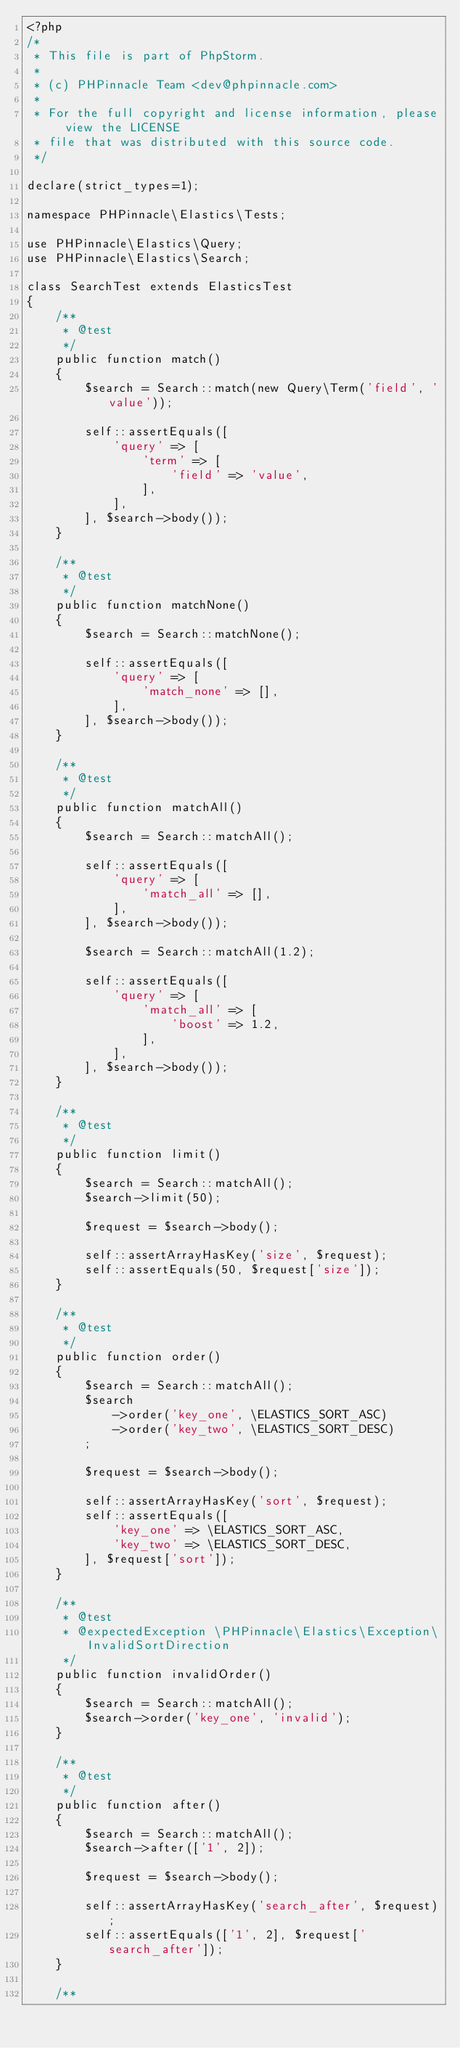<code> <loc_0><loc_0><loc_500><loc_500><_PHP_><?php
/*
 * This file is part of PhpStorm.
 *
 * (c) PHPinnacle Team <dev@phpinnacle.com>
 *
 * For the full copyright and license information, please view the LICENSE
 * file that was distributed with this source code.
 */

declare(strict_types=1);

namespace PHPinnacle\Elastics\Tests;

use PHPinnacle\Elastics\Query;
use PHPinnacle\Elastics\Search;

class SearchTest extends ElasticsTest
{
    /**
     * @test
     */
    public function match()
    {
        $search = Search::match(new Query\Term('field', 'value'));

        self::assertEquals([
            'query' => [
                'term' => [
                    'field' => 'value',
                ],
            ],
        ], $search->body());
    }

    /**
     * @test
     */
    public function matchNone()
    {
        $search = Search::matchNone();

        self::assertEquals([
            'query' => [
                'match_none' => [],
            ],
        ], $search->body());
    }

    /**
     * @test
     */
    public function matchAll()
    {
        $search = Search::matchAll();

        self::assertEquals([
            'query' => [
                'match_all' => [],
            ],
        ], $search->body());

        $search = Search::matchAll(1.2);

        self::assertEquals([
            'query' => [
                'match_all' => [
                    'boost' => 1.2,
                ],
            ],
        ], $search->body());
    }

    /**
     * @test
     */
    public function limit()
    {
        $search = Search::matchAll();
        $search->limit(50);

        $request = $search->body();

        self::assertArrayHasKey('size', $request);
        self::assertEquals(50, $request['size']);
    }

    /**
     * @test
     */
    public function order()
    {
        $search = Search::matchAll();
        $search
            ->order('key_one', \ELASTICS_SORT_ASC)
            ->order('key_two', \ELASTICS_SORT_DESC)
        ;

        $request = $search->body();

        self::assertArrayHasKey('sort', $request);
        self::assertEquals([
            'key_one' => \ELASTICS_SORT_ASC,
            'key_two' => \ELASTICS_SORT_DESC,
        ], $request['sort']);
    }

    /**
     * @test
     * @expectedException \PHPinnacle\Elastics\Exception\InvalidSortDirection
     */
    public function invalidOrder()
    {
        $search = Search::matchAll();
        $search->order('key_one', 'invalid');
    }

    /**
     * @test
     */
    public function after()
    {
        $search = Search::matchAll();
        $search->after(['1', 2]);

        $request = $search->body();

        self::assertArrayHasKey('search_after', $request);
        self::assertEquals(['1', 2], $request['search_after']);
    }

    /**</code> 